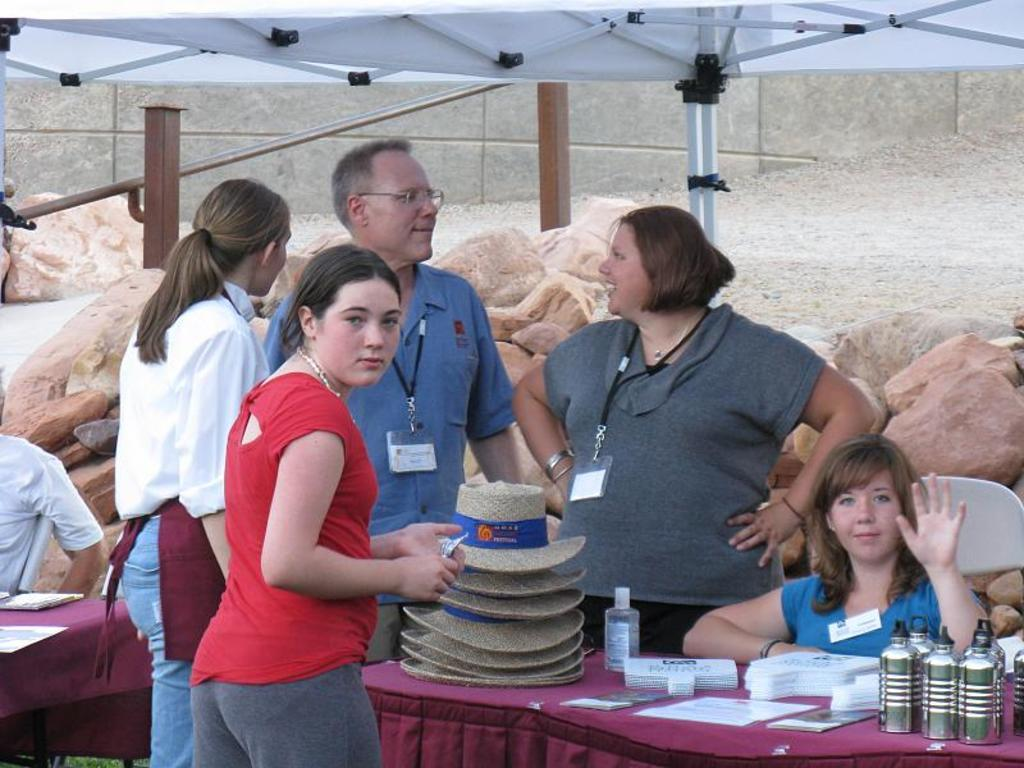How many people are in the image? There is a group of people in the image, but the exact number cannot be determined from the provided facts. What are the people in the image doing? Some people are standing, while others are sitting on chairs. What is present in the image besides the people? There is a table in the image. What can be found on the table? There are objects on the table. What type of zinc is visible on the table in the image? There is no zinc visible on the table in the image. Can you tell me how many bottles of wine are on the table in the image? The provided facts do not mention any wine or bottles on the table, so it cannot be determined from the image. 